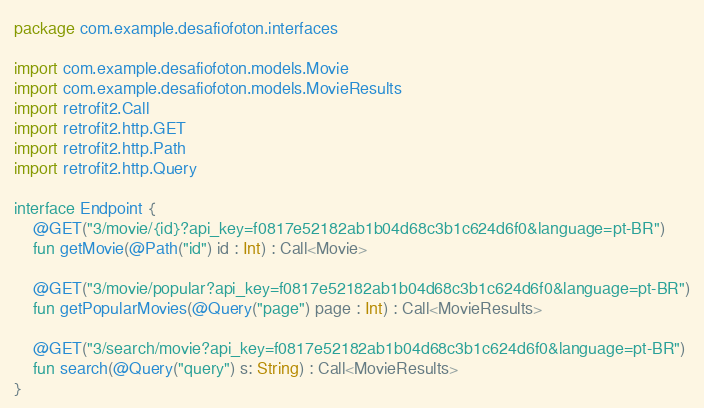Convert code to text. <code><loc_0><loc_0><loc_500><loc_500><_Kotlin_>package com.example.desafiofoton.interfaces

import com.example.desafiofoton.models.Movie
import com.example.desafiofoton.models.MovieResults
import retrofit2.Call
import retrofit2.http.GET
import retrofit2.http.Path
import retrofit2.http.Query

interface Endpoint {
    @GET("3/movie/{id}?api_key=f0817e52182ab1b04d68c3b1c624d6f0&language=pt-BR")
    fun getMovie(@Path("id") id : Int) : Call<Movie>

    @GET("3/movie/popular?api_key=f0817e52182ab1b04d68c3b1c624d6f0&language=pt-BR")
    fun getPopularMovies(@Query("page") page : Int) : Call<MovieResults>

    @GET("3/search/movie?api_key=f0817e52182ab1b04d68c3b1c624d6f0&language=pt-BR")
    fun search(@Query("query") s: String) : Call<MovieResults>
}</code> 